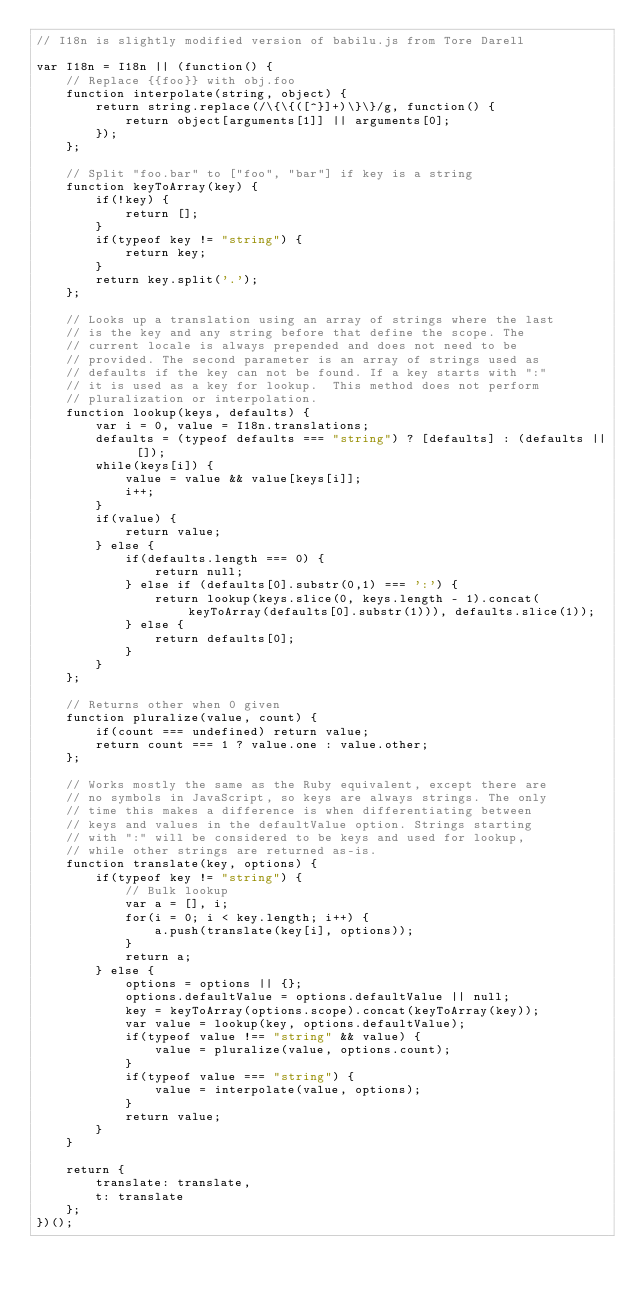Convert code to text. <code><loc_0><loc_0><loc_500><loc_500><_JavaScript_>// I18n is slightly modified version of babilu.js from Tore Darell

var I18n = I18n || (function() {
    // Replace {{foo}} with obj.foo
    function interpolate(string, object) {
        return string.replace(/\{\{([^}]+)\}\}/g, function() {
            return object[arguments[1]] || arguments[0];
        });
    };

    // Split "foo.bar" to ["foo", "bar"] if key is a string
    function keyToArray(key) {
        if(!key) {
            return [];
        }
        if(typeof key != "string") {
            return key;
        }
        return key.split('.');
    };

    // Looks up a translation using an array of strings where the last
    // is the key and any string before that define the scope. The
    // current locale is always prepended and does not need to be
    // provided. The second parameter is an array of strings used as
    // defaults if the key can not be found. If a key starts with ":"
    // it is used as a key for lookup.  This method does not perform
    // pluralization or interpolation.
    function lookup(keys, defaults) {
        var i = 0, value = I18n.translations;
        defaults = (typeof defaults === "string") ? [defaults] : (defaults || []);
        while(keys[i]) {
            value = value && value[keys[i]];
            i++;
        }
        if(value) {
            return value;
        } else {
            if(defaults.length === 0) {
                return null;
            } else if (defaults[0].substr(0,1) === ':') {
                return lookup(keys.slice(0, keys.length - 1).concat(keyToArray(defaults[0].substr(1))), defaults.slice(1));
            } else {
                return defaults[0];
            }
        }
    };

    // Returns other when 0 given
    function pluralize(value, count) {
        if(count === undefined) return value;
        return count === 1 ? value.one : value.other;
    };

    // Works mostly the same as the Ruby equivalent, except there are
    // no symbols in JavaScript, so keys are always strings. The only
    // time this makes a difference is when differentiating between
    // keys and values in the defaultValue option. Strings starting
    // with ":" will be considered to be keys and used for lookup,
    // while other strings are returned as-is.
    function translate(key, options) {
        if(typeof key != "string") {
            // Bulk lookup
            var a = [], i;
            for(i = 0; i < key.length; i++) {
                a.push(translate(key[i], options));
            }
            return a;
        } else {
            options = options || {};
            options.defaultValue = options.defaultValue || null;
            key = keyToArray(options.scope).concat(keyToArray(key));
            var value = lookup(key, options.defaultValue);
            if(typeof value !== "string" && value) {
                value = pluralize(value, options.count);
            }
            if(typeof value === "string") {
                value = interpolate(value, options);
            }
            return value;
        }
    }

    return {
        translate: translate,
        t: translate
    };
})();
</code> 